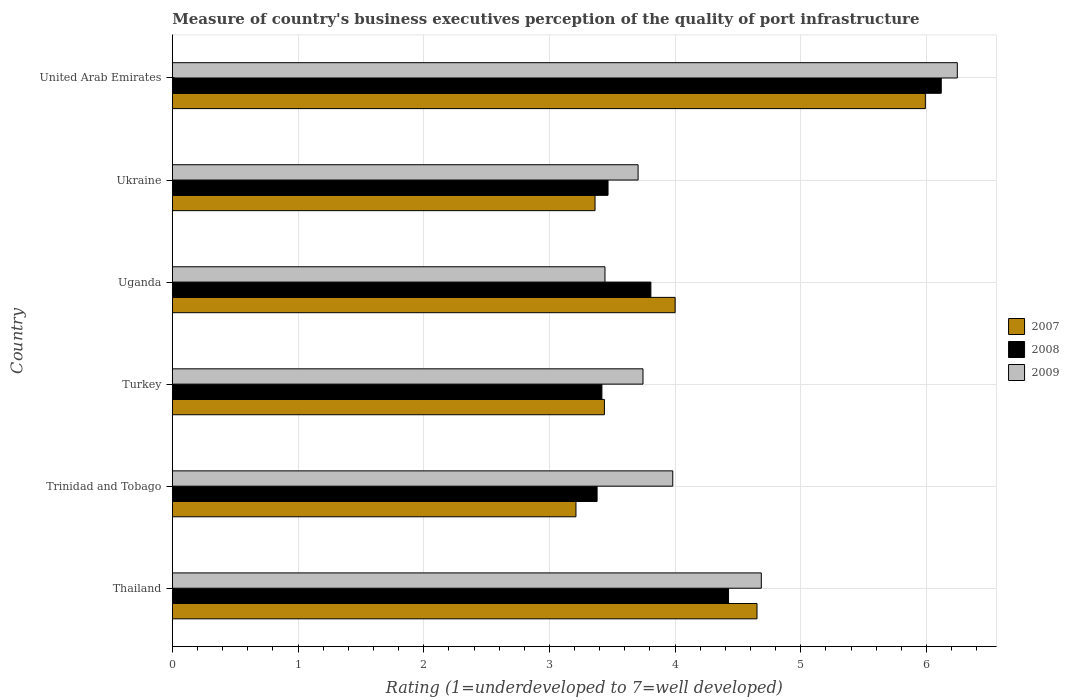How many groups of bars are there?
Ensure brevity in your answer.  6. Are the number of bars per tick equal to the number of legend labels?
Provide a short and direct response. Yes. Are the number of bars on each tick of the Y-axis equal?
Offer a terse response. Yes. How many bars are there on the 4th tick from the top?
Make the answer very short. 3. What is the label of the 3rd group of bars from the top?
Your answer should be very brief. Uganda. In how many cases, is the number of bars for a given country not equal to the number of legend labels?
Your answer should be compact. 0. What is the ratings of the quality of port infrastructure in 2009 in Trinidad and Tobago?
Your answer should be compact. 3.98. Across all countries, what is the maximum ratings of the quality of port infrastructure in 2007?
Make the answer very short. 5.99. Across all countries, what is the minimum ratings of the quality of port infrastructure in 2008?
Offer a very short reply. 3.38. In which country was the ratings of the quality of port infrastructure in 2007 maximum?
Make the answer very short. United Arab Emirates. In which country was the ratings of the quality of port infrastructure in 2007 minimum?
Your answer should be compact. Trinidad and Tobago. What is the total ratings of the quality of port infrastructure in 2009 in the graph?
Your answer should be very brief. 25.8. What is the difference between the ratings of the quality of port infrastructure in 2007 in Turkey and that in Uganda?
Your response must be concise. -0.56. What is the difference between the ratings of the quality of port infrastructure in 2007 in Uganda and the ratings of the quality of port infrastructure in 2009 in Turkey?
Provide a succinct answer. 0.26. What is the average ratings of the quality of port infrastructure in 2009 per country?
Provide a short and direct response. 4.3. What is the difference between the ratings of the quality of port infrastructure in 2007 and ratings of the quality of port infrastructure in 2008 in Uganda?
Give a very brief answer. 0.19. What is the ratio of the ratings of the quality of port infrastructure in 2007 in Ukraine to that in United Arab Emirates?
Offer a terse response. 0.56. Is the ratings of the quality of port infrastructure in 2007 in Thailand less than that in Trinidad and Tobago?
Your answer should be compact. No. What is the difference between the highest and the second highest ratings of the quality of port infrastructure in 2008?
Offer a very short reply. 1.69. What is the difference between the highest and the lowest ratings of the quality of port infrastructure in 2009?
Make the answer very short. 2.8. What does the 1st bar from the bottom in Uganda represents?
Your response must be concise. 2007. Are the values on the major ticks of X-axis written in scientific E-notation?
Offer a very short reply. No. Where does the legend appear in the graph?
Make the answer very short. Center right. How many legend labels are there?
Your answer should be compact. 3. How are the legend labels stacked?
Offer a very short reply. Vertical. What is the title of the graph?
Keep it short and to the point. Measure of country's business executives perception of the quality of port infrastructure. What is the label or title of the X-axis?
Provide a short and direct response. Rating (1=underdeveloped to 7=well developed). What is the Rating (1=underdeveloped to 7=well developed) of 2007 in Thailand?
Ensure brevity in your answer.  4.65. What is the Rating (1=underdeveloped to 7=well developed) in 2008 in Thailand?
Your answer should be compact. 4.42. What is the Rating (1=underdeveloped to 7=well developed) in 2009 in Thailand?
Your answer should be very brief. 4.69. What is the Rating (1=underdeveloped to 7=well developed) of 2007 in Trinidad and Tobago?
Give a very brief answer. 3.21. What is the Rating (1=underdeveloped to 7=well developed) of 2008 in Trinidad and Tobago?
Offer a very short reply. 3.38. What is the Rating (1=underdeveloped to 7=well developed) of 2009 in Trinidad and Tobago?
Ensure brevity in your answer.  3.98. What is the Rating (1=underdeveloped to 7=well developed) in 2007 in Turkey?
Give a very brief answer. 3.44. What is the Rating (1=underdeveloped to 7=well developed) in 2008 in Turkey?
Ensure brevity in your answer.  3.42. What is the Rating (1=underdeveloped to 7=well developed) in 2009 in Turkey?
Ensure brevity in your answer.  3.74. What is the Rating (1=underdeveloped to 7=well developed) in 2007 in Uganda?
Offer a very short reply. 4. What is the Rating (1=underdeveloped to 7=well developed) in 2008 in Uganda?
Offer a very short reply. 3.81. What is the Rating (1=underdeveloped to 7=well developed) in 2009 in Uganda?
Give a very brief answer. 3.44. What is the Rating (1=underdeveloped to 7=well developed) in 2007 in Ukraine?
Give a very brief answer. 3.36. What is the Rating (1=underdeveloped to 7=well developed) in 2008 in Ukraine?
Your response must be concise. 3.47. What is the Rating (1=underdeveloped to 7=well developed) of 2009 in Ukraine?
Ensure brevity in your answer.  3.71. What is the Rating (1=underdeveloped to 7=well developed) in 2007 in United Arab Emirates?
Your answer should be very brief. 5.99. What is the Rating (1=underdeveloped to 7=well developed) of 2008 in United Arab Emirates?
Make the answer very short. 6.12. What is the Rating (1=underdeveloped to 7=well developed) of 2009 in United Arab Emirates?
Make the answer very short. 6.24. Across all countries, what is the maximum Rating (1=underdeveloped to 7=well developed) of 2007?
Provide a succinct answer. 5.99. Across all countries, what is the maximum Rating (1=underdeveloped to 7=well developed) of 2008?
Provide a succinct answer. 6.12. Across all countries, what is the maximum Rating (1=underdeveloped to 7=well developed) of 2009?
Keep it short and to the point. 6.24. Across all countries, what is the minimum Rating (1=underdeveloped to 7=well developed) of 2007?
Your answer should be compact. 3.21. Across all countries, what is the minimum Rating (1=underdeveloped to 7=well developed) in 2008?
Your answer should be very brief. 3.38. Across all countries, what is the minimum Rating (1=underdeveloped to 7=well developed) of 2009?
Give a very brief answer. 3.44. What is the total Rating (1=underdeveloped to 7=well developed) of 2007 in the graph?
Make the answer very short. 24.65. What is the total Rating (1=underdeveloped to 7=well developed) in 2008 in the graph?
Provide a short and direct response. 24.61. What is the total Rating (1=underdeveloped to 7=well developed) of 2009 in the graph?
Your answer should be very brief. 25.8. What is the difference between the Rating (1=underdeveloped to 7=well developed) of 2007 in Thailand and that in Trinidad and Tobago?
Ensure brevity in your answer.  1.44. What is the difference between the Rating (1=underdeveloped to 7=well developed) in 2008 in Thailand and that in Trinidad and Tobago?
Provide a short and direct response. 1.05. What is the difference between the Rating (1=underdeveloped to 7=well developed) in 2009 in Thailand and that in Trinidad and Tobago?
Make the answer very short. 0.7. What is the difference between the Rating (1=underdeveloped to 7=well developed) in 2007 in Thailand and that in Turkey?
Give a very brief answer. 1.21. What is the difference between the Rating (1=underdeveloped to 7=well developed) of 2008 in Thailand and that in Turkey?
Keep it short and to the point. 1.01. What is the difference between the Rating (1=underdeveloped to 7=well developed) of 2009 in Thailand and that in Turkey?
Your answer should be compact. 0.94. What is the difference between the Rating (1=underdeveloped to 7=well developed) in 2007 in Thailand and that in Uganda?
Make the answer very short. 0.65. What is the difference between the Rating (1=underdeveloped to 7=well developed) of 2008 in Thailand and that in Uganda?
Keep it short and to the point. 0.62. What is the difference between the Rating (1=underdeveloped to 7=well developed) of 2009 in Thailand and that in Uganda?
Provide a succinct answer. 1.24. What is the difference between the Rating (1=underdeveloped to 7=well developed) of 2007 in Thailand and that in Ukraine?
Offer a very short reply. 1.29. What is the difference between the Rating (1=underdeveloped to 7=well developed) in 2008 in Thailand and that in Ukraine?
Offer a terse response. 0.96. What is the difference between the Rating (1=underdeveloped to 7=well developed) of 2009 in Thailand and that in Ukraine?
Your response must be concise. 0.98. What is the difference between the Rating (1=underdeveloped to 7=well developed) in 2007 in Thailand and that in United Arab Emirates?
Your response must be concise. -1.34. What is the difference between the Rating (1=underdeveloped to 7=well developed) in 2008 in Thailand and that in United Arab Emirates?
Offer a terse response. -1.69. What is the difference between the Rating (1=underdeveloped to 7=well developed) of 2009 in Thailand and that in United Arab Emirates?
Your answer should be very brief. -1.56. What is the difference between the Rating (1=underdeveloped to 7=well developed) of 2007 in Trinidad and Tobago and that in Turkey?
Ensure brevity in your answer.  -0.23. What is the difference between the Rating (1=underdeveloped to 7=well developed) in 2008 in Trinidad and Tobago and that in Turkey?
Your response must be concise. -0.04. What is the difference between the Rating (1=underdeveloped to 7=well developed) in 2009 in Trinidad and Tobago and that in Turkey?
Your answer should be very brief. 0.24. What is the difference between the Rating (1=underdeveloped to 7=well developed) of 2007 in Trinidad and Tobago and that in Uganda?
Offer a very short reply. -0.79. What is the difference between the Rating (1=underdeveloped to 7=well developed) in 2008 in Trinidad and Tobago and that in Uganda?
Your response must be concise. -0.43. What is the difference between the Rating (1=underdeveloped to 7=well developed) of 2009 in Trinidad and Tobago and that in Uganda?
Your answer should be very brief. 0.54. What is the difference between the Rating (1=underdeveloped to 7=well developed) in 2007 in Trinidad and Tobago and that in Ukraine?
Provide a short and direct response. -0.15. What is the difference between the Rating (1=underdeveloped to 7=well developed) in 2008 in Trinidad and Tobago and that in Ukraine?
Provide a short and direct response. -0.09. What is the difference between the Rating (1=underdeveloped to 7=well developed) of 2009 in Trinidad and Tobago and that in Ukraine?
Ensure brevity in your answer.  0.28. What is the difference between the Rating (1=underdeveloped to 7=well developed) in 2007 in Trinidad and Tobago and that in United Arab Emirates?
Your response must be concise. -2.78. What is the difference between the Rating (1=underdeveloped to 7=well developed) in 2008 in Trinidad and Tobago and that in United Arab Emirates?
Make the answer very short. -2.74. What is the difference between the Rating (1=underdeveloped to 7=well developed) in 2009 in Trinidad and Tobago and that in United Arab Emirates?
Your answer should be compact. -2.26. What is the difference between the Rating (1=underdeveloped to 7=well developed) in 2007 in Turkey and that in Uganda?
Your answer should be compact. -0.56. What is the difference between the Rating (1=underdeveloped to 7=well developed) in 2008 in Turkey and that in Uganda?
Make the answer very short. -0.39. What is the difference between the Rating (1=underdeveloped to 7=well developed) in 2009 in Turkey and that in Uganda?
Give a very brief answer. 0.3. What is the difference between the Rating (1=underdeveloped to 7=well developed) in 2007 in Turkey and that in Ukraine?
Offer a very short reply. 0.07. What is the difference between the Rating (1=underdeveloped to 7=well developed) of 2008 in Turkey and that in Ukraine?
Make the answer very short. -0.05. What is the difference between the Rating (1=underdeveloped to 7=well developed) of 2009 in Turkey and that in Ukraine?
Offer a terse response. 0.04. What is the difference between the Rating (1=underdeveloped to 7=well developed) in 2007 in Turkey and that in United Arab Emirates?
Offer a terse response. -2.55. What is the difference between the Rating (1=underdeveloped to 7=well developed) of 2008 in Turkey and that in United Arab Emirates?
Keep it short and to the point. -2.7. What is the difference between the Rating (1=underdeveloped to 7=well developed) of 2009 in Turkey and that in United Arab Emirates?
Your answer should be very brief. -2.5. What is the difference between the Rating (1=underdeveloped to 7=well developed) of 2007 in Uganda and that in Ukraine?
Offer a terse response. 0.64. What is the difference between the Rating (1=underdeveloped to 7=well developed) of 2008 in Uganda and that in Ukraine?
Ensure brevity in your answer.  0.34. What is the difference between the Rating (1=underdeveloped to 7=well developed) of 2009 in Uganda and that in Ukraine?
Make the answer very short. -0.26. What is the difference between the Rating (1=underdeveloped to 7=well developed) in 2007 in Uganda and that in United Arab Emirates?
Make the answer very short. -1.99. What is the difference between the Rating (1=underdeveloped to 7=well developed) in 2008 in Uganda and that in United Arab Emirates?
Provide a succinct answer. -2.31. What is the difference between the Rating (1=underdeveloped to 7=well developed) in 2009 in Uganda and that in United Arab Emirates?
Your answer should be very brief. -2.8. What is the difference between the Rating (1=underdeveloped to 7=well developed) of 2007 in Ukraine and that in United Arab Emirates?
Your response must be concise. -2.63. What is the difference between the Rating (1=underdeveloped to 7=well developed) of 2008 in Ukraine and that in United Arab Emirates?
Offer a terse response. -2.65. What is the difference between the Rating (1=underdeveloped to 7=well developed) in 2009 in Ukraine and that in United Arab Emirates?
Ensure brevity in your answer.  -2.54. What is the difference between the Rating (1=underdeveloped to 7=well developed) in 2007 in Thailand and the Rating (1=underdeveloped to 7=well developed) in 2008 in Trinidad and Tobago?
Offer a very short reply. 1.27. What is the difference between the Rating (1=underdeveloped to 7=well developed) in 2007 in Thailand and the Rating (1=underdeveloped to 7=well developed) in 2009 in Trinidad and Tobago?
Make the answer very short. 0.67. What is the difference between the Rating (1=underdeveloped to 7=well developed) of 2008 in Thailand and the Rating (1=underdeveloped to 7=well developed) of 2009 in Trinidad and Tobago?
Your answer should be very brief. 0.44. What is the difference between the Rating (1=underdeveloped to 7=well developed) of 2007 in Thailand and the Rating (1=underdeveloped to 7=well developed) of 2008 in Turkey?
Ensure brevity in your answer.  1.23. What is the difference between the Rating (1=underdeveloped to 7=well developed) of 2007 in Thailand and the Rating (1=underdeveloped to 7=well developed) of 2009 in Turkey?
Your response must be concise. 0.91. What is the difference between the Rating (1=underdeveloped to 7=well developed) in 2008 in Thailand and the Rating (1=underdeveloped to 7=well developed) in 2009 in Turkey?
Give a very brief answer. 0.68. What is the difference between the Rating (1=underdeveloped to 7=well developed) in 2007 in Thailand and the Rating (1=underdeveloped to 7=well developed) in 2008 in Uganda?
Make the answer very short. 0.84. What is the difference between the Rating (1=underdeveloped to 7=well developed) in 2007 in Thailand and the Rating (1=underdeveloped to 7=well developed) in 2009 in Uganda?
Keep it short and to the point. 1.21. What is the difference between the Rating (1=underdeveloped to 7=well developed) of 2008 in Thailand and the Rating (1=underdeveloped to 7=well developed) of 2009 in Uganda?
Give a very brief answer. 0.98. What is the difference between the Rating (1=underdeveloped to 7=well developed) of 2007 in Thailand and the Rating (1=underdeveloped to 7=well developed) of 2008 in Ukraine?
Provide a succinct answer. 1.19. What is the difference between the Rating (1=underdeveloped to 7=well developed) in 2007 in Thailand and the Rating (1=underdeveloped to 7=well developed) in 2009 in Ukraine?
Give a very brief answer. 0.95. What is the difference between the Rating (1=underdeveloped to 7=well developed) in 2008 in Thailand and the Rating (1=underdeveloped to 7=well developed) in 2009 in Ukraine?
Your answer should be very brief. 0.72. What is the difference between the Rating (1=underdeveloped to 7=well developed) in 2007 in Thailand and the Rating (1=underdeveloped to 7=well developed) in 2008 in United Arab Emirates?
Make the answer very short. -1.47. What is the difference between the Rating (1=underdeveloped to 7=well developed) of 2007 in Thailand and the Rating (1=underdeveloped to 7=well developed) of 2009 in United Arab Emirates?
Your answer should be very brief. -1.59. What is the difference between the Rating (1=underdeveloped to 7=well developed) of 2008 in Thailand and the Rating (1=underdeveloped to 7=well developed) of 2009 in United Arab Emirates?
Offer a very short reply. -1.82. What is the difference between the Rating (1=underdeveloped to 7=well developed) of 2007 in Trinidad and Tobago and the Rating (1=underdeveloped to 7=well developed) of 2008 in Turkey?
Give a very brief answer. -0.21. What is the difference between the Rating (1=underdeveloped to 7=well developed) in 2007 in Trinidad and Tobago and the Rating (1=underdeveloped to 7=well developed) in 2009 in Turkey?
Give a very brief answer. -0.53. What is the difference between the Rating (1=underdeveloped to 7=well developed) in 2008 in Trinidad and Tobago and the Rating (1=underdeveloped to 7=well developed) in 2009 in Turkey?
Give a very brief answer. -0.37. What is the difference between the Rating (1=underdeveloped to 7=well developed) of 2007 in Trinidad and Tobago and the Rating (1=underdeveloped to 7=well developed) of 2008 in Uganda?
Make the answer very short. -0.6. What is the difference between the Rating (1=underdeveloped to 7=well developed) of 2007 in Trinidad and Tobago and the Rating (1=underdeveloped to 7=well developed) of 2009 in Uganda?
Keep it short and to the point. -0.23. What is the difference between the Rating (1=underdeveloped to 7=well developed) of 2008 in Trinidad and Tobago and the Rating (1=underdeveloped to 7=well developed) of 2009 in Uganda?
Keep it short and to the point. -0.06. What is the difference between the Rating (1=underdeveloped to 7=well developed) in 2007 in Trinidad and Tobago and the Rating (1=underdeveloped to 7=well developed) in 2008 in Ukraine?
Give a very brief answer. -0.26. What is the difference between the Rating (1=underdeveloped to 7=well developed) in 2007 in Trinidad and Tobago and the Rating (1=underdeveloped to 7=well developed) in 2009 in Ukraine?
Make the answer very short. -0.49. What is the difference between the Rating (1=underdeveloped to 7=well developed) of 2008 in Trinidad and Tobago and the Rating (1=underdeveloped to 7=well developed) of 2009 in Ukraine?
Your response must be concise. -0.33. What is the difference between the Rating (1=underdeveloped to 7=well developed) in 2007 in Trinidad and Tobago and the Rating (1=underdeveloped to 7=well developed) in 2008 in United Arab Emirates?
Your answer should be compact. -2.91. What is the difference between the Rating (1=underdeveloped to 7=well developed) in 2007 in Trinidad and Tobago and the Rating (1=underdeveloped to 7=well developed) in 2009 in United Arab Emirates?
Give a very brief answer. -3.03. What is the difference between the Rating (1=underdeveloped to 7=well developed) in 2008 in Trinidad and Tobago and the Rating (1=underdeveloped to 7=well developed) in 2009 in United Arab Emirates?
Your answer should be very brief. -2.87. What is the difference between the Rating (1=underdeveloped to 7=well developed) in 2007 in Turkey and the Rating (1=underdeveloped to 7=well developed) in 2008 in Uganda?
Your answer should be very brief. -0.37. What is the difference between the Rating (1=underdeveloped to 7=well developed) in 2007 in Turkey and the Rating (1=underdeveloped to 7=well developed) in 2009 in Uganda?
Offer a terse response. -0. What is the difference between the Rating (1=underdeveloped to 7=well developed) of 2008 in Turkey and the Rating (1=underdeveloped to 7=well developed) of 2009 in Uganda?
Your answer should be very brief. -0.02. What is the difference between the Rating (1=underdeveloped to 7=well developed) in 2007 in Turkey and the Rating (1=underdeveloped to 7=well developed) in 2008 in Ukraine?
Offer a terse response. -0.03. What is the difference between the Rating (1=underdeveloped to 7=well developed) of 2007 in Turkey and the Rating (1=underdeveloped to 7=well developed) of 2009 in Ukraine?
Provide a succinct answer. -0.27. What is the difference between the Rating (1=underdeveloped to 7=well developed) in 2008 in Turkey and the Rating (1=underdeveloped to 7=well developed) in 2009 in Ukraine?
Your answer should be very brief. -0.29. What is the difference between the Rating (1=underdeveloped to 7=well developed) in 2007 in Turkey and the Rating (1=underdeveloped to 7=well developed) in 2008 in United Arab Emirates?
Keep it short and to the point. -2.68. What is the difference between the Rating (1=underdeveloped to 7=well developed) in 2007 in Turkey and the Rating (1=underdeveloped to 7=well developed) in 2009 in United Arab Emirates?
Your answer should be very brief. -2.81. What is the difference between the Rating (1=underdeveloped to 7=well developed) of 2008 in Turkey and the Rating (1=underdeveloped to 7=well developed) of 2009 in United Arab Emirates?
Provide a succinct answer. -2.83. What is the difference between the Rating (1=underdeveloped to 7=well developed) in 2007 in Uganda and the Rating (1=underdeveloped to 7=well developed) in 2008 in Ukraine?
Give a very brief answer. 0.53. What is the difference between the Rating (1=underdeveloped to 7=well developed) of 2007 in Uganda and the Rating (1=underdeveloped to 7=well developed) of 2009 in Ukraine?
Provide a short and direct response. 0.29. What is the difference between the Rating (1=underdeveloped to 7=well developed) of 2008 in Uganda and the Rating (1=underdeveloped to 7=well developed) of 2009 in Ukraine?
Offer a terse response. 0.1. What is the difference between the Rating (1=underdeveloped to 7=well developed) of 2007 in Uganda and the Rating (1=underdeveloped to 7=well developed) of 2008 in United Arab Emirates?
Your answer should be compact. -2.12. What is the difference between the Rating (1=underdeveloped to 7=well developed) in 2007 in Uganda and the Rating (1=underdeveloped to 7=well developed) in 2009 in United Arab Emirates?
Offer a very short reply. -2.25. What is the difference between the Rating (1=underdeveloped to 7=well developed) of 2008 in Uganda and the Rating (1=underdeveloped to 7=well developed) of 2009 in United Arab Emirates?
Your response must be concise. -2.44. What is the difference between the Rating (1=underdeveloped to 7=well developed) in 2007 in Ukraine and the Rating (1=underdeveloped to 7=well developed) in 2008 in United Arab Emirates?
Give a very brief answer. -2.75. What is the difference between the Rating (1=underdeveloped to 7=well developed) in 2007 in Ukraine and the Rating (1=underdeveloped to 7=well developed) in 2009 in United Arab Emirates?
Offer a very short reply. -2.88. What is the difference between the Rating (1=underdeveloped to 7=well developed) of 2008 in Ukraine and the Rating (1=underdeveloped to 7=well developed) of 2009 in United Arab Emirates?
Keep it short and to the point. -2.78. What is the average Rating (1=underdeveloped to 7=well developed) in 2007 per country?
Offer a very short reply. 4.11. What is the average Rating (1=underdeveloped to 7=well developed) in 2008 per country?
Your response must be concise. 4.1. What is the average Rating (1=underdeveloped to 7=well developed) of 2009 per country?
Provide a short and direct response. 4.3. What is the difference between the Rating (1=underdeveloped to 7=well developed) of 2007 and Rating (1=underdeveloped to 7=well developed) of 2008 in Thailand?
Provide a succinct answer. 0.23. What is the difference between the Rating (1=underdeveloped to 7=well developed) of 2007 and Rating (1=underdeveloped to 7=well developed) of 2009 in Thailand?
Offer a terse response. -0.03. What is the difference between the Rating (1=underdeveloped to 7=well developed) in 2008 and Rating (1=underdeveloped to 7=well developed) in 2009 in Thailand?
Provide a short and direct response. -0.26. What is the difference between the Rating (1=underdeveloped to 7=well developed) of 2007 and Rating (1=underdeveloped to 7=well developed) of 2008 in Trinidad and Tobago?
Keep it short and to the point. -0.17. What is the difference between the Rating (1=underdeveloped to 7=well developed) in 2007 and Rating (1=underdeveloped to 7=well developed) in 2009 in Trinidad and Tobago?
Ensure brevity in your answer.  -0.77. What is the difference between the Rating (1=underdeveloped to 7=well developed) of 2008 and Rating (1=underdeveloped to 7=well developed) of 2009 in Trinidad and Tobago?
Offer a terse response. -0.6. What is the difference between the Rating (1=underdeveloped to 7=well developed) of 2007 and Rating (1=underdeveloped to 7=well developed) of 2008 in Turkey?
Keep it short and to the point. 0.02. What is the difference between the Rating (1=underdeveloped to 7=well developed) of 2007 and Rating (1=underdeveloped to 7=well developed) of 2009 in Turkey?
Your answer should be compact. -0.31. What is the difference between the Rating (1=underdeveloped to 7=well developed) of 2008 and Rating (1=underdeveloped to 7=well developed) of 2009 in Turkey?
Make the answer very short. -0.33. What is the difference between the Rating (1=underdeveloped to 7=well developed) in 2007 and Rating (1=underdeveloped to 7=well developed) in 2008 in Uganda?
Provide a succinct answer. 0.19. What is the difference between the Rating (1=underdeveloped to 7=well developed) of 2007 and Rating (1=underdeveloped to 7=well developed) of 2009 in Uganda?
Give a very brief answer. 0.56. What is the difference between the Rating (1=underdeveloped to 7=well developed) in 2008 and Rating (1=underdeveloped to 7=well developed) in 2009 in Uganda?
Give a very brief answer. 0.37. What is the difference between the Rating (1=underdeveloped to 7=well developed) of 2007 and Rating (1=underdeveloped to 7=well developed) of 2008 in Ukraine?
Offer a terse response. -0.1. What is the difference between the Rating (1=underdeveloped to 7=well developed) of 2007 and Rating (1=underdeveloped to 7=well developed) of 2009 in Ukraine?
Make the answer very short. -0.34. What is the difference between the Rating (1=underdeveloped to 7=well developed) of 2008 and Rating (1=underdeveloped to 7=well developed) of 2009 in Ukraine?
Provide a succinct answer. -0.24. What is the difference between the Rating (1=underdeveloped to 7=well developed) of 2007 and Rating (1=underdeveloped to 7=well developed) of 2008 in United Arab Emirates?
Your answer should be very brief. -0.13. What is the difference between the Rating (1=underdeveloped to 7=well developed) of 2007 and Rating (1=underdeveloped to 7=well developed) of 2009 in United Arab Emirates?
Your answer should be very brief. -0.25. What is the difference between the Rating (1=underdeveloped to 7=well developed) in 2008 and Rating (1=underdeveloped to 7=well developed) in 2009 in United Arab Emirates?
Provide a succinct answer. -0.13. What is the ratio of the Rating (1=underdeveloped to 7=well developed) of 2007 in Thailand to that in Trinidad and Tobago?
Your response must be concise. 1.45. What is the ratio of the Rating (1=underdeveloped to 7=well developed) of 2008 in Thailand to that in Trinidad and Tobago?
Your response must be concise. 1.31. What is the ratio of the Rating (1=underdeveloped to 7=well developed) of 2009 in Thailand to that in Trinidad and Tobago?
Your response must be concise. 1.18. What is the ratio of the Rating (1=underdeveloped to 7=well developed) of 2007 in Thailand to that in Turkey?
Offer a very short reply. 1.35. What is the ratio of the Rating (1=underdeveloped to 7=well developed) of 2008 in Thailand to that in Turkey?
Give a very brief answer. 1.29. What is the ratio of the Rating (1=underdeveloped to 7=well developed) in 2009 in Thailand to that in Turkey?
Offer a very short reply. 1.25. What is the ratio of the Rating (1=underdeveloped to 7=well developed) in 2007 in Thailand to that in Uganda?
Your answer should be very brief. 1.16. What is the ratio of the Rating (1=underdeveloped to 7=well developed) of 2008 in Thailand to that in Uganda?
Provide a short and direct response. 1.16. What is the ratio of the Rating (1=underdeveloped to 7=well developed) of 2009 in Thailand to that in Uganda?
Ensure brevity in your answer.  1.36. What is the ratio of the Rating (1=underdeveloped to 7=well developed) in 2007 in Thailand to that in Ukraine?
Your answer should be compact. 1.38. What is the ratio of the Rating (1=underdeveloped to 7=well developed) of 2008 in Thailand to that in Ukraine?
Provide a short and direct response. 1.28. What is the ratio of the Rating (1=underdeveloped to 7=well developed) in 2009 in Thailand to that in Ukraine?
Provide a short and direct response. 1.26. What is the ratio of the Rating (1=underdeveloped to 7=well developed) in 2007 in Thailand to that in United Arab Emirates?
Give a very brief answer. 0.78. What is the ratio of the Rating (1=underdeveloped to 7=well developed) in 2008 in Thailand to that in United Arab Emirates?
Offer a very short reply. 0.72. What is the ratio of the Rating (1=underdeveloped to 7=well developed) in 2009 in Thailand to that in United Arab Emirates?
Your response must be concise. 0.75. What is the ratio of the Rating (1=underdeveloped to 7=well developed) in 2007 in Trinidad and Tobago to that in Turkey?
Keep it short and to the point. 0.93. What is the ratio of the Rating (1=underdeveloped to 7=well developed) of 2009 in Trinidad and Tobago to that in Turkey?
Your answer should be compact. 1.06. What is the ratio of the Rating (1=underdeveloped to 7=well developed) in 2007 in Trinidad and Tobago to that in Uganda?
Your answer should be compact. 0.8. What is the ratio of the Rating (1=underdeveloped to 7=well developed) in 2008 in Trinidad and Tobago to that in Uganda?
Your response must be concise. 0.89. What is the ratio of the Rating (1=underdeveloped to 7=well developed) in 2009 in Trinidad and Tobago to that in Uganda?
Your response must be concise. 1.16. What is the ratio of the Rating (1=underdeveloped to 7=well developed) of 2007 in Trinidad and Tobago to that in Ukraine?
Your response must be concise. 0.95. What is the ratio of the Rating (1=underdeveloped to 7=well developed) in 2008 in Trinidad and Tobago to that in Ukraine?
Your response must be concise. 0.97. What is the ratio of the Rating (1=underdeveloped to 7=well developed) in 2009 in Trinidad and Tobago to that in Ukraine?
Make the answer very short. 1.07. What is the ratio of the Rating (1=underdeveloped to 7=well developed) of 2007 in Trinidad and Tobago to that in United Arab Emirates?
Make the answer very short. 0.54. What is the ratio of the Rating (1=underdeveloped to 7=well developed) of 2008 in Trinidad and Tobago to that in United Arab Emirates?
Provide a succinct answer. 0.55. What is the ratio of the Rating (1=underdeveloped to 7=well developed) in 2009 in Trinidad and Tobago to that in United Arab Emirates?
Your answer should be very brief. 0.64. What is the ratio of the Rating (1=underdeveloped to 7=well developed) in 2007 in Turkey to that in Uganda?
Offer a terse response. 0.86. What is the ratio of the Rating (1=underdeveloped to 7=well developed) of 2008 in Turkey to that in Uganda?
Ensure brevity in your answer.  0.9. What is the ratio of the Rating (1=underdeveloped to 7=well developed) of 2009 in Turkey to that in Uganda?
Your answer should be compact. 1.09. What is the ratio of the Rating (1=underdeveloped to 7=well developed) of 2007 in Turkey to that in Ukraine?
Make the answer very short. 1.02. What is the ratio of the Rating (1=underdeveloped to 7=well developed) of 2009 in Turkey to that in Ukraine?
Offer a terse response. 1.01. What is the ratio of the Rating (1=underdeveloped to 7=well developed) in 2007 in Turkey to that in United Arab Emirates?
Make the answer very short. 0.57. What is the ratio of the Rating (1=underdeveloped to 7=well developed) of 2008 in Turkey to that in United Arab Emirates?
Make the answer very short. 0.56. What is the ratio of the Rating (1=underdeveloped to 7=well developed) of 2009 in Turkey to that in United Arab Emirates?
Ensure brevity in your answer.  0.6. What is the ratio of the Rating (1=underdeveloped to 7=well developed) of 2007 in Uganda to that in Ukraine?
Offer a terse response. 1.19. What is the ratio of the Rating (1=underdeveloped to 7=well developed) of 2008 in Uganda to that in Ukraine?
Make the answer very short. 1.1. What is the ratio of the Rating (1=underdeveloped to 7=well developed) of 2009 in Uganda to that in Ukraine?
Offer a terse response. 0.93. What is the ratio of the Rating (1=underdeveloped to 7=well developed) of 2007 in Uganda to that in United Arab Emirates?
Your answer should be very brief. 0.67. What is the ratio of the Rating (1=underdeveloped to 7=well developed) in 2008 in Uganda to that in United Arab Emirates?
Your answer should be compact. 0.62. What is the ratio of the Rating (1=underdeveloped to 7=well developed) of 2009 in Uganda to that in United Arab Emirates?
Keep it short and to the point. 0.55. What is the ratio of the Rating (1=underdeveloped to 7=well developed) of 2007 in Ukraine to that in United Arab Emirates?
Offer a very short reply. 0.56. What is the ratio of the Rating (1=underdeveloped to 7=well developed) in 2008 in Ukraine to that in United Arab Emirates?
Give a very brief answer. 0.57. What is the ratio of the Rating (1=underdeveloped to 7=well developed) in 2009 in Ukraine to that in United Arab Emirates?
Provide a succinct answer. 0.59. What is the difference between the highest and the second highest Rating (1=underdeveloped to 7=well developed) of 2007?
Provide a short and direct response. 1.34. What is the difference between the highest and the second highest Rating (1=underdeveloped to 7=well developed) of 2008?
Your answer should be compact. 1.69. What is the difference between the highest and the second highest Rating (1=underdeveloped to 7=well developed) of 2009?
Provide a short and direct response. 1.56. What is the difference between the highest and the lowest Rating (1=underdeveloped to 7=well developed) of 2007?
Your response must be concise. 2.78. What is the difference between the highest and the lowest Rating (1=underdeveloped to 7=well developed) in 2008?
Your response must be concise. 2.74. What is the difference between the highest and the lowest Rating (1=underdeveloped to 7=well developed) of 2009?
Provide a short and direct response. 2.8. 